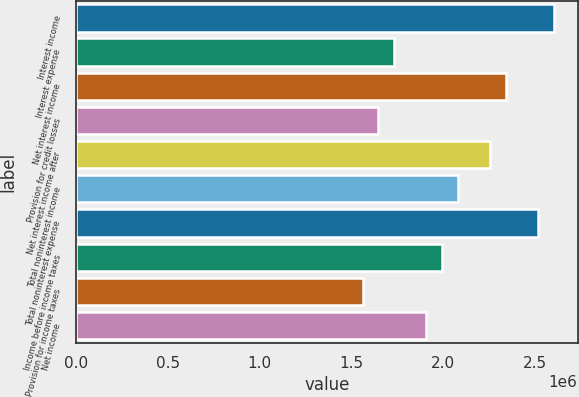<chart> <loc_0><loc_0><loc_500><loc_500><bar_chart><fcel>Interest income<fcel>Interest expense<fcel>Net interest income<fcel>Provision for credit losses<fcel>Net interest income after<fcel>Total noninterest income<fcel>Total noninterest expense<fcel>Income before income taxes<fcel>Provision for income taxes<fcel>Net income<nl><fcel>2.60447e+06<fcel>1.73631e+06<fcel>2.34402e+06<fcel>1.6495e+06<fcel>2.25721e+06<fcel>2.08357e+06<fcel>2.51765e+06<fcel>1.99676e+06<fcel>1.56268e+06<fcel>1.90994e+06<nl></chart> 